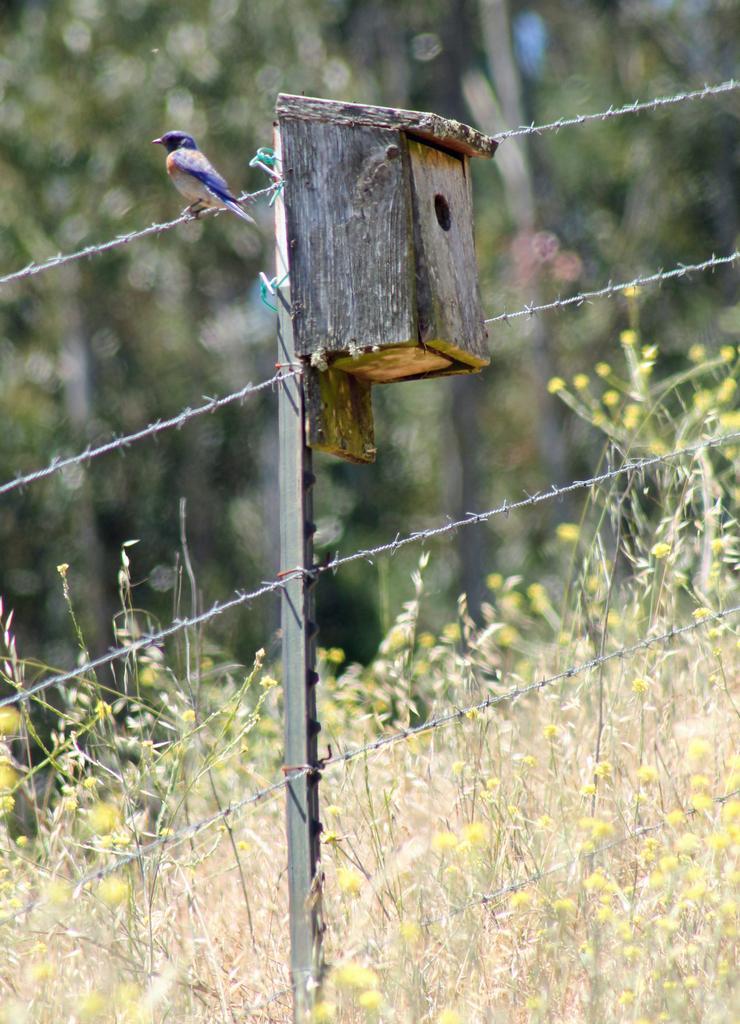How would you summarize this image in a sentence or two? Here we can see a birdhouse, rod, and a bird on the fence. In the background we can see plants and trees. 